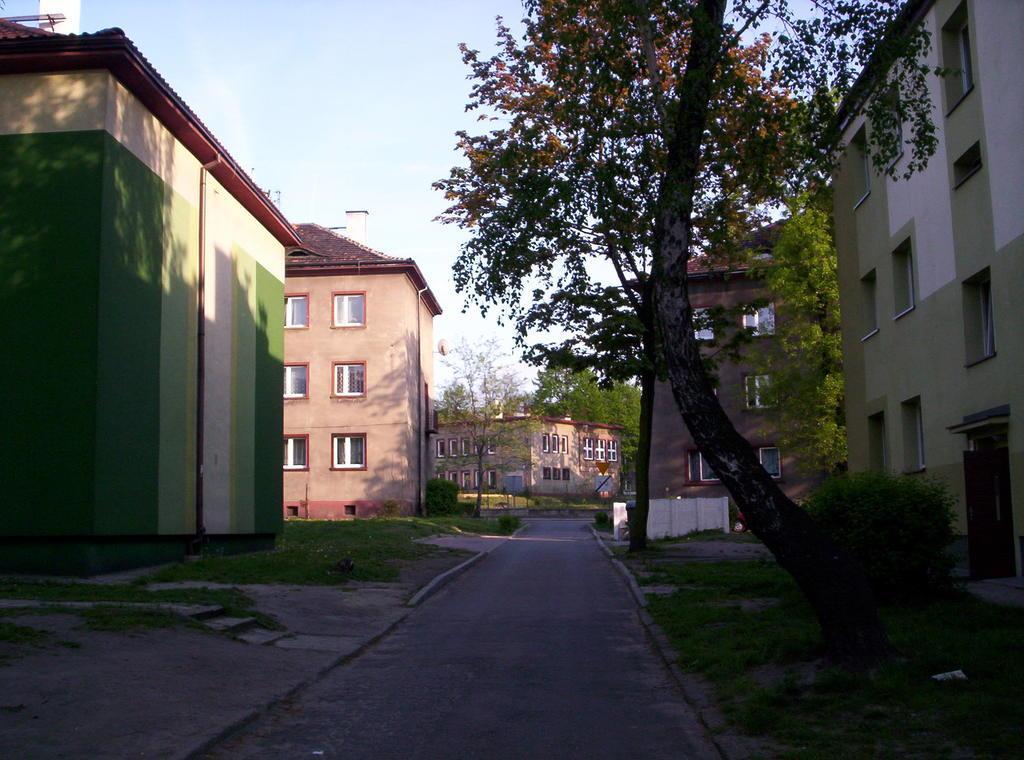In one or two sentences, can you explain what this image depicts? In this image, we can see buildings. There are some trees in the middle of the image. There is a plant in the bottom right of the image. At the top of the image, we can see the sky. 